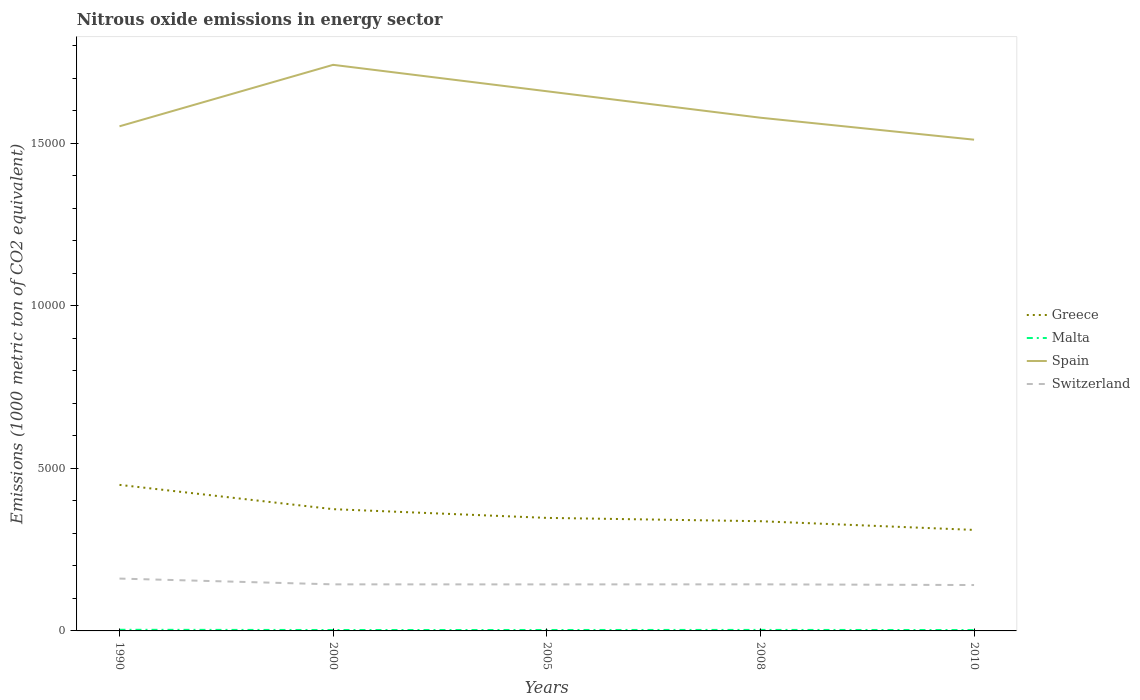How many different coloured lines are there?
Your answer should be compact. 4. Does the line corresponding to Spain intersect with the line corresponding to Greece?
Your answer should be very brief. No. Across all years, what is the maximum amount of nitrous oxide emitted in Greece?
Provide a succinct answer. 3107.1. In which year was the amount of nitrous oxide emitted in Switzerland maximum?
Keep it short and to the point. 2010. What is the total amount of nitrous oxide emitted in Spain in the graph?
Provide a succinct answer. 814.2. What is the difference between the highest and the second highest amount of nitrous oxide emitted in Spain?
Keep it short and to the point. 2302.5. Is the amount of nitrous oxide emitted in Greece strictly greater than the amount of nitrous oxide emitted in Spain over the years?
Give a very brief answer. Yes. How many lines are there?
Offer a very short reply. 4. How many years are there in the graph?
Give a very brief answer. 5. Where does the legend appear in the graph?
Ensure brevity in your answer.  Center right. How many legend labels are there?
Provide a succinct answer. 4. How are the legend labels stacked?
Your answer should be very brief. Vertical. What is the title of the graph?
Your answer should be very brief. Nitrous oxide emissions in energy sector. What is the label or title of the X-axis?
Provide a short and direct response. Years. What is the label or title of the Y-axis?
Provide a short and direct response. Emissions (1000 metric ton of CO2 equivalent). What is the Emissions (1000 metric ton of CO2 equivalent) of Greece in 1990?
Keep it short and to the point. 4492.8. What is the Emissions (1000 metric ton of CO2 equivalent) of Spain in 1990?
Ensure brevity in your answer.  1.55e+04. What is the Emissions (1000 metric ton of CO2 equivalent) in Switzerland in 1990?
Offer a very short reply. 1610.2. What is the Emissions (1000 metric ton of CO2 equivalent) in Greece in 2000?
Offer a terse response. 3745.5. What is the Emissions (1000 metric ton of CO2 equivalent) of Malta in 2000?
Provide a succinct answer. 28.2. What is the Emissions (1000 metric ton of CO2 equivalent) of Spain in 2000?
Your answer should be compact. 1.74e+04. What is the Emissions (1000 metric ton of CO2 equivalent) of Switzerland in 2000?
Provide a succinct answer. 1432.5. What is the Emissions (1000 metric ton of CO2 equivalent) of Greece in 2005?
Provide a succinct answer. 3477. What is the Emissions (1000 metric ton of CO2 equivalent) in Malta in 2005?
Offer a terse response. 28.7. What is the Emissions (1000 metric ton of CO2 equivalent) in Spain in 2005?
Offer a terse response. 1.66e+04. What is the Emissions (1000 metric ton of CO2 equivalent) of Switzerland in 2005?
Offer a terse response. 1431.1. What is the Emissions (1000 metric ton of CO2 equivalent) of Greece in 2008?
Your answer should be very brief. 3375. What is the Emissions (1000 metric ton of CO2 equivalent) in Malta in 2008?
Offer a very short reply. 31.1. What is the Emissions (1000 metric ton of CO2 equivalent) of Spain in 2008?
Your response must be concise. 1.58e+04. What is the Emissions (1000 metric ton of CO2 equivalent) in Switzerland in 2008?
Offer a very short reply. 1433. What is the Emissions (1000 metric ton of CO2 equivalent) in Greece in 2010?
Your answer should be compact. 3107.1. What is the Emissions (1000 metric ton of CO2 equivalent) of Malta in 2010?
Your response must be concise. 27.4. What is the Emissions (1000 metric ton of CO2 equivalent) in Spain in 2010?
Provide a succinct answer. 1.51e+04. What is the Emissions (1000 metric ton of CO2 equivalent) of Switzerland in 2010?
Your response must be concise. 1411.6. Across all years, what is the maximum Emissions (1000 metric ton of CO2 equivalent) of Greece?
Provide a short and direct response. 4492.8. Across all years, what is the maximum Emissions (1000 metric ton of CO2 equivalent) of Malta?
Ensure brevity in your answer.  35. Across all years, what is the maximum Emissions (1000 metric ton of CO2 equivalent) of Spain?
Offer a very short reply. 1.74e+04. Across all years, what is the maximum Emissions (1000 metric ton of CO2 equivalent) of Switzerland?
Give a very brief answer. 1610.2. Across all years, what is the minimum Emissions (1000 metric ton of CO2 equivalent) in Greece?
Make the answer very short. 3107.1. Across all years, what is the minimum Emissions (1000 metric ton of CO2 equivalent) of Malta?
Give a very brief answer. 27.4. Across all years, what is the minimum Emissions (1000 metric ton of CO2 equivalent) in Spain?
Ensure brevity in your answer.  1.51e+04. Across all years, what is the minimum Emissions (1000 metric ton of CO2 equivalent) in Switzerland?
Give a very brief answer. 1411.6. What is the total Emissions (1000 metric ton of CO2 equivalent) in Greece in the graph?
Provide a short and direct response. 1.82e+04. What is the total Emissions (1000 metric ton of CO2 equivalent) of Malta in the graph?
Offer a terse response. 150.4. What is the total Emissions (1000 metric ton of CO2 equivalent) of Spain in the graph?
Provide a succinct answer. 8.04e+04. What is the total Emissions (1000 metric ton of CO2 equivalent) in Switzerland in the graph?
Provide a short and direct response. 7318.4. What is the difference between the Emissions (1000 metric ton of CO2 equivalent) of Greece in 1990 and that in 2000?
Give a very brief answer. 747.3. What is the difference between the Emissions (1000 metric ton of CO2 equivalent) in Spain in 1990 and that in 2000?
Ensure brevity in your answer.  -1890.8. What is the difference between the Emissions (1000 metric ton of CO2 equivalent) in Switzerland in 1990 and that in 2000?
Your answer should be very brief. 177.7. What is the difference between the Emissions (1000 metric ton of CO2 equivalent) of Greece in 1990 and that in 2005?
Ensure brevity in your answer.  1015.8. What is the difference between the Emissions (1000 metric ton of CO2 equivalent) in Malta in 1990 and that in 2005?
Provide a short and direct response. 6.3. What is the difference between the Emissions (1000 metric ton of CO2 equivalent) in Spain in 1990 and that in 2005?
Your response must be concise. -1078.3. What is the difference between the Emissions (1000 metric ton of CO2 equivalent) of Switzerland in 1990 and that in 2005?
Give a very brief answer. 179.1. What is the difference between the Emissions (1000 metric ton of CO2 equivalent) in Greece in 1990 and that in 2008?
Ensure brevity in your answer.  1117.8. What is the difference between the Emissions (1000 metric ton of CO2 equivalent) in Malta in 1990 and that in 2008?
Make the answer very short. 3.9. What is the difference between the Emissions (1000 metric ton of CO2 equivalent) of Spain in 1990 and that in 2008?
Keep it short and to the point. -264.1. What is the difference between the Emissions (1000 metric ton of CO2 equivalent) in Switzerland in 1990 and that in 2008?
Ensure brevity in your answer.  177.2. What is the difference between the Emissions (1000 metric ton of CO2 equivalent) in Greece in 1990 and that in 2010?
Provide a succinct answer. 1385.7. What is the difference between the Emissions (1000 metric ton of CO2 equivalent) of Malta in 1990 and that in 2010?
Your response must be concise. 7.6. What is the difference between the Emissions (1000 metric ton of CO2 equivalent) in Spain in 1990 and that in 2010?
Keep it short and to the point. 411.7. What is the difference between the Emissions (1000 metric ton of CO2 equivalent) in Switzerland in 1990 and that in 2010?
Offer a very short reply. 198.6. What is the difference between the Emissions (1000 metric ton of CO2 equivalent) in Greece in 2000 and that in 2005?
Give a very brief answer. 268.5. What is the difference between the Emissions (1000 metric ton of CO2 equivalent) in Spain in 2000 and that in 2005?
Provide a short and direct response. 812.5. What is the difference between the Emissions (1000 metric ton of CO2 equivalent) in Greece in 2000 and that in 2008?
Keep it short and to the point. 370.5. What is the difference between the Emissions (1000 metric ton of CO2 equivalent) of Malta in 2000 and that in 2008?
Provide a short and direct response. -2.9. What is the difference between the Emissions (1000 metric ton of CO2 equivalent) in Spain in 2000 and that in 2008?
Provide a short and direct response. 1626.7. What is the difference between the Emissions (1000 metric ton of CO2 equivalent) of Greece in 2000 and that in 2010?
Provide a short and direct response. 638.4. What is the difference between the Emissions (1000 metric ton of CO2 equivalent) in Spain in 2000 and that in 2010?
Your answer should be compact. 2302.5. What is the difference between the Emissions (1000 metric ton of CO2 equivalent) of Switzerland in 2000 and that in 2010?
Keep it short and to the point. 20.9. What is the difference between the Emissions (1000 metric ton of CO2 equivalent) in Greece in 2005 and that in 2008?
Your answer should be very brief. 102. What is the difference between the Emissions (1000 metric ton of CO2 equivalent) in Spain in 2005 and that in 2008?
Offer a terse response. 814.2. What is the difference between the Emissions (1000 metric ton of CO2 equivalent) of Switzerland in 2005 and that in 2008?
Keep it short and to the point. -1.9. What is the difference between the Emissions (1000 metric ton of CO2 equivalent) in Greece in 2005 and that in 2010?
Offer a very short reply. 369.9. What is the difference between the Emissions (1000 metric ton of CO2 equivalent) of Malta in 2005 and that in 2010?
Your answer should be compact. 1.3. What is the difference between the Emissions (1000 metric ton of CO2 equivalent) in Spain in 2005 and that in 2010?
Provide a succinct answer. 1490. What is the difference between the Emissions (1000 metric ton of CO2 equivalent) in Greece in 2008 and that in 2010?
Offer a very short reply. 267.9. What is the difference between the Emissions (1000 metric ton of CO2 equivalent) in Malta in 2008 and that in 2010?
Give a very brief answer. 3.7. What is the difference between the Emissions (1000 metric ton of CO2 equivalent) of Spain in 2008 and that in 2010?
Offer a very short reply. 675.8. What is the difference between the Emissions (1000 metric ton of CO2 equivalent) of Switzerland in 2008 and that in 2010?
Give a very brief answer. 21.4. What is the difference between the Emissions (1000 metric ton of CO2 equivalent) of Greece in 1990 and the Emissions (1000 metric ton of CO2 equivalent) of Malta in 2000?
Your response must be concise. 4464.6. What is the difference between the Emissions (1000 metric ton of CO2 equivalent) of Greece in 1990 and the Emissions (1000 metric ton of CO2 equivalent) of Spain in 2000?
Give a very brief answer. -1.29e+04. What is the difference between the Emissions (1000 metric ton of CO2 equivalent) in Greece in 1990 and the Emissions (1000 metric ton of CO2 equivalent) in Switzerland in 2000?
Offer a terse response. 3060.3. What is the difference between the Emissions (1000 metric ton of CO2 equivalent) in Malta in 1990 and the Emissions (1000 metric ton of CO2 equivalent) in Spain in 2000?
Your answer should be compact. -1.74e+04. What is the difference between the Emissions (1000 metric ton of CO2 equivalent) of Malta in 1990 and the Emissions (1000 metric ton of CO2 equivalent) of Switzerland in 2000?
Ensure brevity in your answer.  -1397.5. What is the difference between the Emissions (1000 metric ton of CO2 equivalent) of Spain in 1990 and the Emissions (1000 metric ton of CO2 equivalent) of Switzerland in 2000?
Provide a succinct answer. 1.41e+04. What is the difference between the Emissions (1000 metric ton of CO2 equivalent) in Greece in 1990 and the Emissions (1000 metric ton of CO2 equivalent) in Malta in 2005?
Make the answer very short. 4464.1. What is the difference between the Emissions (1000 metric ton of CO2 equivalent) in Greece in 1990 and the Emissions (1000 metric ton of CO2 equivalent) in Spain in 2005?
Give a very brief answer. -1.21e+04. What is the difference between the Emissions (1000 metric ton of CO2 equivalent) in Greece in 1990 and the Emissions (1000 metric ton of CO2 equivalent) in Switzerland in 2005?
Offer a very short reply. 3061.7. What is the difference between the Emissions (1000 metric ton of CO2 equivalent) in Malta in 1990 and the Emissions (1000 metric ton of CO2 equivalent) in Spain in 2005?
Provide a short and direct response. -1.66e+04. What is the difference between the Emissions (1000 metric ton of CO2 equivalent) in Malta in 1990 and the Emissions (1000 metric ton of CO2 equivalent) in Switzerland in 2005?
Ensure brevity in your answer.  -1396.1. What is the difference between the Emissions (1000 metric ton of CO2 equivalent) in Spain in 1990 and the Emissions (1000 metric ton of CO2 equivalent) in Switzerland in 2005?
Offer a very short reply. 1.41e+04. What is the difference between the Emissions (1000 metric ton of CO2 equivalent) of Greece in 1990 and the Emissions (1000 metric ton of CO2 equivalent) of Malta in 2008?
Your response must be concise. 4461.7. What is the difference between the Emissions (1000 metric ton of CO2 equivalent) in Greece in 1990 and the Emissions (1000 metric ton of CO2 equivalent) in Spain in 2008?
Your answer should be very brief. -1.13e+04. What is the difference between the Emissions (1000 metric ton of CO2 equivalent) of Greece in 1990 and the Emissions (1000 metric ton of CO2 equivalent) of Switzerland in 2008?
Provide a succinct answer. 3059.8. What is the difference between the Emissions (1000 metric ton of CO2 equivalent) in Malta in 1990 and the Emissions (1000 metric ton of CO2 equivalent) in Spain in 2008?
Keep it short and to the point. -1.58e+04. What is the difference between the Emissions (1000 metric ton of CO2 equivalent) of Malta in 1990 and the Emissions (1000 metric ton of CO2 equivalent) of Switzerland in 2008?
Your answer should be compact. -1398. What is the difference between the Emissions (1000 metric ton of CO2 equivalent) in Spain in 1990 and the Emissions (1000 metric ton of CO2 equivalent) in Switzerland in 2008?
Give a very brief answer. 1.41e+04. What is the difference between the Emissions (1000 metric ton of CO2 equivalent) in Greece in 1990 and the Emissions (1000 metric ton of CO2 equivalent) in Malta in 2010?
Make the answer very short. 4465.4. What is the difference between the Emissions (1000 metric ton of CO2 equivalent) of Greece in 1990 and the Emissions (1000 metric ton of CO2 equivalent) of Spain in 2010?
Provide a short and direct response. -1.06e+04. What is the difference between the Emissions (1000 metric ton of CO2 equivalent) of Greece in 1990 and the Emissions (1000 metric ton of CO2 equivalent) of Switzerland in 2010?
Your response must be concise. 3081.2. What is the difference between the Emissions (1000 metric ton of CO2 equivalent) of Malta in 1990 and the Emissions (1000 metric ton of CO2 equivalent) of Spain in 2010?
Keep it short and to the point. -1.51e+04. What is the difference between the Emissions (1000 metric ton of CO2 equivalent) in Malta in 1990 and the Emissions (1000 metric ton of CO2 equivalent) in Switzerland in 2010?
Offer a terse response. -1376.6. What is the difference between the Emissions (1000 metric ton of CO2 equivalent) of Spain in 1990 and the Emissions (1000 metric ton of CO2 equivalent) of Switzerland in 2010?
Provide a succinct answer. 1.41e+04. What is the difference between the Emissions (1000 metric ton of CO2 equivalent) in Greece in 2000 and the Emissions (1000 metric ton of CO2 equivalent) in Malta in 2005?
Offer a very short reply. 3716.8. What is the difference between the Emissions (1000 metric ton of CO2 equivalent) in Greece in 2000 and the Emissions (1000 metric ton of CO2 equivalent) in Spain in 2005?
Offer a very short reply. -1.29e+04. What is the difference between the Emissions (1000 metric ton of CO2 equivalent) in Greece in 2000 and the Emissions (1000 metric ton of CO2 equivalent) in Switzerland in 2005?
Offer a terse response. 2314.4. What is the difference between the Emissions (1000 metric ton of CO2 equivalent) of Malta in 2000 and the Emissions (1000 metric ton of CO2 equivalent) of Spain in 2005?
Make the answer very short. -1.66e+04. What is the difference between the Emissions (1000 metric ton of CO2 equivalent) of Malta in 2000 and the Emissions (1000 metric ton of CO2 equivalent) of Switzerland in 2005?
Offer a terse response. -1402.9. What is the difference between the Emissions (1000 metric ton of CO2 equivalent) of Spain in 2000 and the Emissions (1000 metric ton of CO2 equivalent) of Switzerland in 2005?
Ensure brevity in your answer.  1.60e+04. What is the difference between the Emissions (1000 metric ton of CO2 equivalent) of Greece in 2000 and the Emissions (1000 metric ton of CO2 equivalent) of Malta in 2008?
Your answer should be compact. 3714.4. What is the difference between the Emissions (1000 metric ton of CO2 equivalent) of Greece in 2000 and the Emissions (1000 metric ton of CO2 equivalent) of Spain in 2008?
Make the answer very short. -1.20e+04. What is the difference between the Emissions (1000 metric ton of CO2 equivalent) of Greece in 2000 and the Emissions (1000 metric ton of CO2 equivalent) of Switzerland in 2008?
Ensure brevity in your answer.  2312.5. What is the difference between the Emissions (1000 metric ton of CO2 equivalent) in Malta in 2000 and the Emissions (1000 metric ton of CO2 equivalent) in Spain in 2008?
Offer a terse response. -1.58e+04. What is the difference between the Emissions (1000 metric ton of CO2 equivalent) of Malta in 2000 and the Emissions (1000 metric ton of CO2 equivalent) of Switzerland in 2008?
Provide a succinct answer. -1404.8. What is the difference between the Emissions (1000 metric ton of CO2 equivalent) in Spain in 2000 and the Emissions (1000 metric ton of CO2 equivalent) in Switzerland in 2008?
Ensure brevity in your answer.  1.60e+04. What is the difference between the Emissions (1000 metric ton of CO2 equivalent) in Greece in 2000 and the Emissions (1000 metric ton of CO2 equivalent) in Malta in 2010?
Make the answer very short. 3718.1. What is the difference between the Emissions (1000 metric ton of CO2 equivalent) of Greece in 2000 and the Emissions (1000 metric ton of CO2 equivalent) of Spain in 2010?
Ensure brevity in your answer.  -1.14e+04. What is the difference between the Emissions (1000 metric ton of CO2 equivalent) in Greece in 2000 and the Emissions (1000 metric ton of CO2 equivalent) in Switzerland in 2010?
Give a very brief answer. 2333.9. What is the difference between the Emissions (1000 metric ton of CO2 equivalent) of Malta in 2000 and the Emissions (1000 metric ton of CO2 equivalent) of Spain in 2010?
Give a very brief answer. -1.51e+04. What is the difference between the Emissions (1000 metric ton of CO2 equivalent) in Malta in 2000 and the Emissions (1000 metric ton of CO2 equivalent) in Switzerland in 2010?
Provide a short and direct response. -1383.4. What is the difference between the Emissions (1000 metric ton of CO2 equivalent) in Spain in 2000 and the Emissions (1000 metric ton of CO2 equivalent) in Switzerland in 2010?
Give a very brief answer. 1.60e+04. What is the difference between the Emissions (1000 metric ton of CO2 equivalent) of Greece in 2005 and the Emissions (1000 metric ton of CO2 equivalent) of Malta in 2008?
Provide a short and direct response. 3445.9. What is the difference between the Emissions (1000 metric ton of CO2 equivalent) in Greece in 2005 and the Emissions (1000 metric ton of CO2 equivalent) in Spain in 2008?
Ensure brevity in your answer.  -1.23e+04. What is the difference between the Emissions (1000 metric ton of CO2 equivalent) in Greece in 2005 and the Emissions (1000 metric ton of CO2 equivalent) in Switzerland in 2008?
Make the answer very short. 2044. What is the difference between the Emissions (1000 metric ton of CO2 equivalent) of Malta in 2005 and the Emissions (1000 metric ton of CO2 equivalent) of Spain in 2008?
Make the answer very short. -1.58e+04. What is the difference between the Emissions (1000 metric ton of CO2 equivalent) of Malta in 2005 and the Emissions (1000 metric ton of CO2 equivalent) of Switzerland in 2008?
Keep it short and to the point. -1404.3. What is the difference between the Emissions (1000 metric ton of CO2 equivalent) in Spain in 2005 and the Emissions (1000 metric ton of CO2 equivalent) in Switzerland in 2008?
Offer a terse response. 1.52e+04. What is the difference between the Emissions (1000 metric ton of CO2 equivalent) in Greece in 2005 and the Emissions (1000 metric ton of CO2 equivalent) in Malta in 2010?
Provide a short and direct response. 3449.6. What is the difference between the Emissions (1000 metric ton of CO2 equivalent) of Greece in 2005 and the Emissions (1000 metric ton of CO2 equivalent) of Spain in 2010?
Ensure brevity in your answer.  -1.16e+04. What is the difference between the Emissions (1000 metric ton of CO2 equivalent) of Greece in 2005 and the Emissions (1000 metric ton of CO2 equivalent) of Switzerland in 2010?
Your answer should be compact. 2065.4. What is the difference between the Emissions (1000 metric ton of CO2 equivalent) of Malta in 2005 and the Emissions (1000 metric ton of CO2 equivalent) of Spain in 2010?
Offer a terse response. -1.51e+04. What is the difference between the Emissions (1000 metric ton of CO2 equivalent) in Malta in 2005 and the Emissions (1000 metric ton of CO2 equivalent) in Switzerland in 2010?
Offer a very short reply. -1382.9. What is the difference between the Emissions (1000 metric ton of CO2 equivalent) of Spain in 2005 and the Emissions (1000 metric ton of CO2 equivalent) of Switzerland in 2010?
Provide a succinct answer. 1.52e+04. What is the difference between the Emissions (1000 metric ton of CO2 equivalent) in Greece in 2008 and the Emissions (1000 metric ton of CO2 equivalent) in Malta in 2010?
Provide a short and direct response. 3347.6. What is the difference between the Emissions (1000 metric ton of CO2 equivalent) in Greece in 2008 and the Emissions (1000 metric ton of CO2 equivalent) in Spain in 2010?
Provide a short and direct response. -1.17e+04. What is the difference between the Emissions (1000 metric ton of CO2 equivalent) of Greece in 2008 and the Emissions (1000 metric ton of CO2 equivalent) of Switzerland in 2010?
Provide a short and direct response. 1963.4. What is the difference between the Emissions (1000 metric ton of CO2 equivalent) of Malta in 2008 and the Emissions (1000 metric ton of CO2 equivalent) of Spain in 2010?
Ensure brevity in your answer.  -1.51e+04. What is the difference between the Emissions (1000 metric ton of CO2 equivalent) of Malta in 2008 and the Emissions (1000 metric ton of CO2 equivalent) of Switzerland in 2010?
Offer a terse response. -1380.5. What is the difference between the Emissions (1000 metric ton of CO2 equivalent) of Spain in 2008 and the Emissions (1000 metric ton of CO2 equivalent) of Switzerland in 2010?
Offer a terse response. 1.44e+04. What is the average Emissions (1000 metric ton of CO2 equivalent) of Greece per year?
Offer a terse response. 3639.48. What is the average Emissions (1000 metric ton of CO2 equivalent) in Malta per year?
Offer a terse response. 30.08. What is the average Emissions (1000 metric ton of CO2 equivalent) of Spain per year?
Provide a succinct answer. 1.61e+04. What is the average Emissions (1000 metric ton of CO2 equivalent) in Switzerland per year?
Make the answer very short. 1463.68. In the year 1990, what is the difference between the Emissions (1000 metric ton of CO2 equivalent) in Greece and Emissions (1000 metric ton of CO2 equivalent) in Malta?
Make the answer very short. 4457.8. In the year 1990, what is the difference between the Emissions (1000 metric ton of CO2 equivalent) in Greece and Emissions (1000 metric ton of CO2 equivalent) in Spain?
Ensure brevity in your answer.  -1.10e+04. In the year 1990, what is the difference between the Emissions (1000 metric ton of CO2 equivalent) in Greece and Emissions (1000 metric ton of CO2 equivalent) in Switzerland?
Offer a very short reply. 2882.6. In the year 1990, what is the difference between the Emissions (1000 metric ton of CO2 equivalent) of Malta and Emissions (1000 metric ton of CO2 equivalent) of Spain?
Keep it short and to the point. -1.55e+04. In the year 1990, what is the difference between the Emissions (1000 metric ton of CO2 equivalent) in Malta and Emissions (1000 metric ton of CO2 equivalent) in Switzerland?
Ensure brevity in your answer.  -1575.2. In the year 1990, what is the difference between the Emissions (1000 metric ton of CO2 equivalent) in Spain and Emissions (1000 metric ton of CO2 equivalent) in Switzerland?
Give a very brief answer. 1.39e+04. In the year 2000, what is the difference between the Emissions (1000 metric ton of CO2 equivalent) in Greece and Emissions (1000 metric ton of CO2 equivalent) in Malta?
Offer a terse response. 3717.3. In the year 2000, what is the difference between the Emissions (1000 metric ton of CO2 equivalent) in Greece and Emissions (1000 metric ton of CO2 equivalent) in Spain?
Offer a terse response. -1.37e+04. In the year 2000, what is the difference between the Emissions (1000 metric ton of CO2 equivalent) of Greece and Emissions (1000 metric ton of CO2 equivalent) of Switzerland?
Your answer should be very brief. 2313. In the year 2000, what is the difference between the Emissions (1000 metric ton of CO2 equivalent) of Malta and Emissions (1000 metric ton of CO2 equivalent) of Spain?
Your answer should be compact. -1.74e+04. In the year 2000, what is the difference between the Emissions (1000 metric ton of CO2 equivalent) in Malta and Emissions (1000 metric ton of CO2 equivalent) in Switzerland?
Offer a terse response. -1404.3. In the year 2000, what is the difference between the Emissions (1000 metric ton of CO2 equivalent) of Spain and Emissions (1000 metric ton of CO2 equivalent) of Switzerland?
Give a very brief answer. 1.60e+04. In the year 2005, what is the difference between the Emissions (1000 metric ton of CO2 equivalent) in Greece and Emissions (1000 metric ton of CO2 equivalent) in Malta?
Your answer should be very brief. 3448.3. In the year 2005, what is the difference between the Emissions (1000 metric ton of CO2 equivalent) of Greece and Emissions (1000 metric ton of CO2 equivalent) of Spain?
Make the answer very short. -1.31e+04. In the year 2005, what is the difference between the Emissions (1000 metric ton of CO2 equivalent) of Greece and Emissions (1000 metric ton of CO2 equivalent) of Switzerland?
Provide a succinct answer. 2045.9. In the year 2005, what is the difference between the Emissions (1000 metric ton of CO2 equivalent) of Malta and Emissions (1000 metric ton of CO2 equivalent) of Spain?
Provide a succinct answer. -1.66e+04. In the year 2005, what is the difference between the Emissions (1000 metric ton of CO2 equivalent) in Malta and Emissions (1000 metric ton of CO2 equivalent) in Switzerland?
Make the answer very short. -1402.4. In the year 2005, what is the difference between the Emissions (1000 metric ton of CO2 equivalent) of Spain and Emissions (1000 metric ton of CO2 equivalent) of Switzerland?
Offer a very short reply. 1.52e+04. In the year 2008, what is the difference between the Emissions (1000 metric ton of CO2 equivalent) of Greece and Emissions (1000 metric ton of CO2 equivalent) of Malta?
Offer a terse response. 3343.9. In the year 2008, what is the difference between the Emissions (1000 metric ton of CO2 equivalent) in Greece and Emissions (1000 metric ton of CO2 equivalent) in Spain?
Give a very brief answer. -1.24e+04. In the year 2008, what is the difference between the Emissions (1000 metric ton of CO2 equivalent) of Greece and Emissions (1000 metric ton of CO2 equivalent) of Switzerland?
Make the answer very short. 1942. In the year 2008, what is the difference between the Emissions (1000 metric ton of CO2 equivalent) of Malta and Emissions (1000 metric ton of CO2 equivalent) of Spain?
Provide a short and direct response. -1.58e+04. In the year 2008, what is the difference between the Emissions (1000 metric ton of CO2 equivalent) in Malta and Emissions (1000 metric ton of CO2 equivalent) in Switzerland?
Provide a short and direct response. -1401.9. In the year 2008, what is the difference between the Emissions (1000 metric ton of CO2 equivalent) in Spain and Emissions (1000 metric ton of CO2 equivalent) in Switzerland?
Offer a terse response. 1.44e+04. In the year 2010, what is the difference between the Emissions (1000 metric ton of CO2 equivalent) in Greece and Emissions (1000 metric ton of CO2 equivalent) in Malta?
Ensure brevity in your answer.  3079.7. In the year 2010, what is the difference between the Emissions (1000 metric ton of CO2 equivalent) of Greece and Emissions (1000 metric ton of CO2 equivalent) of Spain?
Provide a succinct answer. -1.20e+04. In the year 2010, what is the difference between the Emissions (1000 metric ton of CO2 equivalent) of Greece and Emissions (1000 metric ton of CO2 equivalent) of Switzerland?
Keep it short and to the point. 1695.5. In the year 2010, what is the difference between the Emissions (1000 metric ton of CO2 equivalent) of Malta and Emissions (1000 metric ton of CO2 equivalent) of Spain?
Provide a succinct answer. -1.51e+04. In the year 2010, what is the difference between the Emissions (1000 metric ton of CO2 equivalent) in Malta and Emissions (1000 metric ton of CO2 equivalent) in Switzerland?
Keep it short and to the point. -1384.2. In the year 2010, what is the difference between the Emissions (1000 metric ton of CO2 equivalent) in Spain and Emissions (1000 metric ton of CO2 equivalent) in Switzerland?
Give a very brief answer. 1.37e+04. What is the ratio of the Emissions (1000 metric ton of CO2 equivalent) in Greece in 1990 to that in 2000?
Offer a terse response. 1.2. What is the ratio of the Emissions (1000 metric ton of CO2 equivalent) of Malta in 1990 to that in 2000?
Give a very brief answer. 1.24. What is the ratio of the Emissions (1000 metric ton of CO2 equivalent) in Spain in 1990 to that in 2000?
Provide a short and direct response. 0.89. What is the ratio of the Emissions (1000 metric ton of CO2 equivalent) in Switzerland in 1990 to that in 2000?
Ensure brevity in your answer.  1.12. What is the ratio of the Emissions (1000 metric ton of CO2 equivalent) in Greece in 1990 to that in 2005?
Ensure brevity in your answer.  1.29. What is the ratio of the Emissions (1000 metric ton of CO2 equivalent) in Malta in 1990 to that in 2005?
Your response must be concise. 1.22. What is the ratio of the Emissions (1000 metric ton of CO2 equivalent) of Spain in 1990 to that in 2005?
Your answer should be compact. 0.94. What is the ratio of the Emissions (1000 metric ton of CO2 equivalent) in Switzerland in 1990 to that in 2005?
Your answer should be compact. 1.13. What is the ratio of the Emissions (1000 metric ton of CO2 equivalent) of Greece in 1990 to that in 2008?
Provide a short and direct response. 1.33. What is the ratio of the Emissions (1000 metric ton of CO2 equivalent) in Malta in 1990 to that in 2008?
Offer a terse response. 1.13. What is the ratio of the Emissions (1000 metric ton of CO2 equivalent) in Spain in 1990 to that in 2008?
Make the answer very short. 0.98. What is the ratio of the Emissions (1000 metric ton of CO2 equivalent) in Switzerland in 1990 to that in 2008?
Offer a terse response. 1.12. What is the ratio of the Emissions (1000 metric ton of CO2 equivalent) in Greece in 1990 to that in 2010?
Give a very brief answer. 1.45. What is the ratio of the Emissions (1000 metric ton of CO2 equivalent) of Malta in 1990 to that in 2010?
Your answer should be very brief. 1.28. What is the ratio of the Emissions (1000 metric ton of CO2 equivalent) in Spain in 1990 to that in 2010?
Keep it short and to the point. 1.03. What is the ratio of the Emissions (1000 metric ton of CO2 equivalent) of Switzerland in 1990 to that in 2010?
Provide a succinct answer. 1.14. What is the ratio of the Emissions (1000 metric ton of CO2 equivalent) in Greece in 2000 to that in 2005?
Give a very brief answer. 1.08. What is the ratio of the Emissions (1000 metric ton of CO2 equivalent) in Malta in 2000 to that in 2005?
Your response must be concise. 0.98. What is the ratio of the Emissions (1000 metric ton of CO2 equivalent) of Spain in 2000 to that in 2005?
Provide a short and direct response. 1.05. What is the ratio of the Emissions (1000 metric ton of CO2 equivalent) in Switzerland in 2000 to that in 2005?
Provide a succinct answer. 1. What is the ratio of the Emissions (1000 metric ton of CO2 equivalent) in Greece in 2000 to that in 2008?
Offer a terse response. 1.11. What is the ratio of the Emissions (1000 metric ton of CO2 equivalent) in Malta in 2000 to that in 2008?
Your response must be concise. 0.91. What is the ratio of the Emissions (1000 metric ton of CO2 equivalent) of Spain in 2000 to that in 2008?
Provide a succinct answer. 1.1. What is the ratio of the Emissions (1000 metric ton of CO2 equivalent) of Greece in 2000 to that in 2010?
Provide a short and direct response. 1.21. What is the ratio of the Emissions (1000 metric ton of CO2 equivalent) in Malta in 2000 to that in 2010?
Keep it short and to the point. 1.03. What is the ratio of the Emissions (1000 metric ton of CO2 equivalent) of Spain in 2000 to that in 2010?
Give a very brief answer. 1.15. What is the ratio of the Emissions (1000 metric ton of CO2 equivalent) of Switzerland in 2000 to that in 2010?
Provide a short and direct response. 1.01. What is the ratio of the Emissions (1000 metric ton of CO2 equivalent) in Greece in 2005 to that in 2008?
Ensure brevity in your answer.  1.03. What is the ratio of the Emissions (1000 metric ton of CO2 equivalent) in Malta in 2005 to that in 2008?
Offer a very short reply. 0.92. What is the ratio of the Emissions (1000 metric ton of CO2 equivalent) in Spain in 2005 to that in 2008?
Your answer should be compact. 1.05. What is the ratio of the Emissions (1000 metric ton of CO2 equivalent) of Greece in 2005 to that in 2010?
Give a very brief answer. 1.12. What is the ratio of the Emissions (1000 metric ton of CO2 equivalent) of Malta in 2005 to that in 2010?
Offer a terse response. 1.05. What is the ratio of the Emissions (1000 metric ton of CO2 equivalent) in Spain in 2005 to that in 2010?
Your answer should be compact. 1.1. What is the ratio of the Emissions (1000 metric ton of CO2 equivalent) in Switzerland in 2005 to that in 2010?
Your answer should be very brief. 1.01. What is the ratio of the Emissions (1000 metric ton of CO2 equivalent) of Greece in 2008 to that in 2010?
Provide a succinct answer. 1.09. What is the ratio of the Emissions (1000 metric ton of CO2 equivalent) in Malta in 2008 to that in 2010?
Provide a succinct answer. 1.14. What is the ratio of the Emissions (1000 metric ton of CO2 equivalent) in Spain in 2008 to that in 2010?
Keep it short and to the point. 1.04. What is the ratio of the Emissions (1000 metric ton of CO2 equivalent) of Switzerland in 2008 to that in 2010?
Give a very brief answer. 1.02. What is the difference between the highest and the second highest Emissions (1000 metric ton of CO2 equivalent) of Greece?
Provide a short and direct response. 747.3. What is the difference between the highest and the second highest Emissions (1000 metric ton of CO2 equivalent) of Spain?
Offer a very short reply. 812.5. What is the difference between the highest and the second highest Emissions (1000 metric ton of CO2 equivalent) in Switzerland?
Make the answer very short. 177.2. What is the difference between the highest and the lowest Emissions (1000 metric ton of CO2 equivalent) in Greece?
Your response must be concise. 1385.7. What is the difference between the highest and the lowest Emissions (1000 metric ton of CO2 equivalent) of Spain?
Your answer should be compact. 2302.5. What is the difference between the highest and the lowest Emissions (1000 metric ton of CO2 equivalent) of Switzerland?
Make the answer very short. 198.6. 